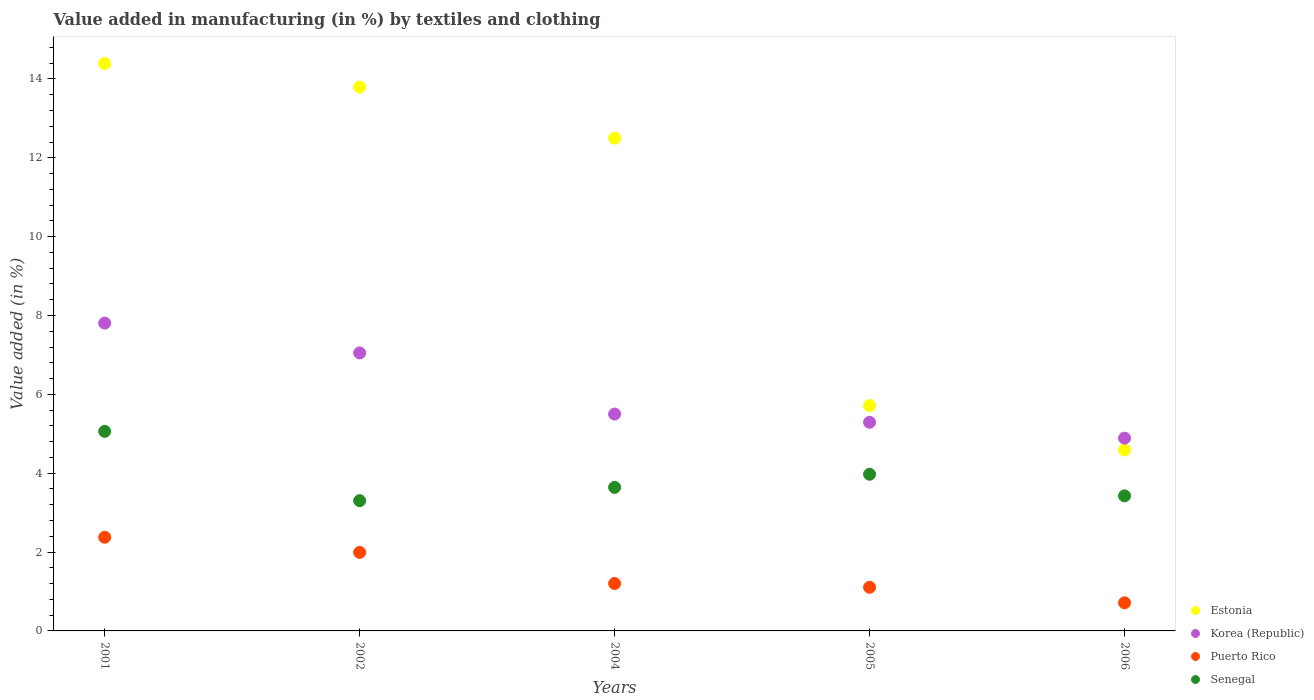How many different coloured dotlines are there?
Your answer should be very brief. 4. What is the percentage of value added in manufacturing by textiles and clothing in Senegal in 2005?
Offer a terse response. 3.97. Across all years, what is the maximum percentage of value added in manufacturing by textiles and clothing in Estonia?
Provide a short and direct response. 14.39. Across all years, what is the minimum percentage of value added in manufacturing by textiles and clothing in Korea (Republic)?
Offer a terse response. 4.89. In which year was the percentage of value added in manufacturing by textiles and clothing in Senegal minimum?
Provide a succinct answer. 2002. What is the total percentage of value added in manufacturing by textiles and clothing in Senegal in the graph?
Your response must be concise. 19.41. What is the difference between the percentage of value added in manufacturing by textiles and clothing in Puerto Rico in 2002 and that in 2005?
Make the answer very short. 0.88. What is the difference between the percentage of value added in manufacturing by textiles and clothing in Senegal in 2004 and the percentage of value added in manufacturing by textiles and clothing in Puerto Rico in 2005?
Offer a very short reply. 2.53. What is the average percentage of value added in manufacturing by textiles and clothing in Korea (Republic) per year?
Make the answer very short. 6.11. In the year 2004, what is the difference between the percentage of value added in manufacturing by textiles and clothing in Korea (Republic) and percentage of value added in manufacturing by textiles and clothing in Estonia?
Provide a succinct answer. -7. What is the ratio of the percentage of value added in manufacturing by textiles and clothing in Korea (Republic) in 2002 to that in 2006?
Offer a terse response. 1.44. Is the difference between the percentage of value added in manufacturing by textiles and clothing in Korea (Republic) in 2001 and 2005 greater than the difference between the percentage of value added in manufacturing by textiles and clothing in Estonia in 2001 and 2005?
Keep it short and to the point. No. What is the difference between the highest and the second highest percentage of value added in manufacturing by textiles and clothing in Senegal?
Offer a very short reply. 1.09. What is the difference between the highest and the lowest percentage of value added in manufacturing by textiles and clothing in Puerto Rico?
Make the answer very short. 1.66. Is the sum of the percentage of value added in manufacturing by textiles and clothing in Korea (Republic) in 2001 and 2006 greater than the maximum percentage of value added in manufacturing by textiles and clothing in Puerto Rico across all years?
Offer a terse response. Yes. Is it the case that in every year, the sum of the percentage of value added in manufacturing by textiles and clothing in Senegal and percentage of value added in manufacturing by textiles and clothing in Puerto Rico  is greater than the sum of percentage of value added in manufacturing by textiles and clothing in Estonia and percentage of value added in manufacturing by textiles and clothing in Korea (Republic)?
Provide a succinct answer. No. Does the percentage of value added in manufacturing by textiles and clothing in Puerto Rico monotonically increase over the years?
Provide a succinct answer. No. How many dotlines are there?
Keep it short and to the point. 4. How many years are there in the graph?
Offer a very short reply. 5. Are the values on the major ticks of Y-axis written in scientific E-notation?
Your answer should be very brief. No. How are the legend labels stacked?
Your response must be concise. Vertical. What is the title of the graph?
Keep it short and to the point. Value added in manufacturing (in %) by textiles and clothing. Does "Other small states" appear as one of the legend labels in the graph?
Offer a very short reply. No. What is the label or title of the X-axis?
Keep it short and to the point. Years. What is the label or title of the Y-axis?
Keep it short and to the point. Value added (in %). What is the Value added (in %) of Estonia in 2001?
Offer a very short reply. 14.39. What is the Value added (in %) of Korea (Republic) in 2001?
Your response must be concise. 7.81. What is the Value added (in %) of Puerto Rico in 2001?
Ensure brevity in your answer.  2.38. What is the Value added (in %) of Senegal in 2001?
Keep it short and to the point. 5.06. What is the Value added (in %) in Estonia in 2002?
Ensure brevity in your answer.  13.79. What is the Value added (in %) in Korea (Republic) in 2002?
Make the answer very short. 7.05. What is the Value added (in %) of Puerto Rico in 2002?
Offer a very short reply. 1.99. What is the Value added (in %) of Senegal in 2002?
Offer a very short reply. 3.3. What is the Value added (in %) of Estonia in 2004?
Provide a short and direct response. 12.5. What is the Value added (in %) of Korea (Republic) in 2004?
Give a very brief answer. 5.5. What is the Value added (in %) in Puerto Rico in 2004?
Give a very brief answer. 1.2. What is the Value added (in %) of Senegal in 2004?
Give a very brief answer. 3.64. What is the Value added (in %) of Estonia in 2005?
Your answer should be compact. 5.72. What is the Value added (in %) in Korea (Republic) in 2005?
Keep it short and to the point. 5.29. What is the Value added (in %) of Puerto Rico in 2005?
Provide a short and direct response. 1.11. What is the Value added (in %) in Senegal in 2005?
Your answer should be very brief. 3.97. What is the Value added (in %) in Estonia in 2006?
Offer a very short reply. 4.59. What is the Value added (in %) in Korea (Republic) in 2006?
Offer a very short reply. 4.89. What is the Value added (in %) in Puerto Rico in 2006?
Provide a short and direct response. 0.71. What is the Value added (in %) in Senegal in 2006?
Your answer should be very brief. 3.43. Across all years, what is the maximum Value added (in %) of Estonia?
Your answer should be very brief. 14.39. Across all years, what is the maximum Value added (in %) of Korea (Republic)?
Offer a very short reply. 7.81. Across all years, what is the maximum Value added (in %) of Puerto Rico?
Provide a short and direct response. 2.38. Across all years, what is the maximum Value added (in %) in Senegal?
Your response must be concise. 5.06. Across all years, what is the minimum Value added (in %) of Estonia?
Provide a short and direct response. 4.59. Across all years, what is the minimum Value added (in %) in Korea (Republic)?
Ensure brevity in your answer.  4.89. Across all years, what is the minimum Value added (in %) of Puerto Rico?
Your response must be concise. 0.71. Across all years, what is the minimum Value added (in %) in Senegal?
Your response must be concise. 3.3. What is the total Value added (in %) of Estonia in the graph?
Your response must be concise. 50.99. What is the total Value added (in %) in Korea (Republic) in the graph?
Offer a very short reply. 30.54. What is the total Value added (in %) in Puerto Rico in the graph?
Your answer should be very brief. 7.39. What is the total Value added (in %) in Senegal in the graph?
Ensure brevity in your answer.  19.41. What is the difference between the Value added (in %) of Estonia in 2001 and that in 2002?
Give a very brief answer. 0.6. What is the difference between the Value added (in %) in Korea (Republic) in 2001 and that in 2002?
Offer a terse response. 0.76. What is the difference between the Value added (in %) of Puerto Rico in 2001 and that in 2002?
Provide a succinct answer. 0.38. What is the difference between the Value added (in %) in Senegal in 2001 and that in 2002?
Keep it short and to the point. 1.76. What is the difference between the Value added (in %) of Estonia in 2001 and that in 2004?
Provide a succinct answer. 1.89. What is the difference between the Value added (in %) of Korea (Republic) in 2001 and that in 2004?
Ensure brevity in your answer.  2.31. What is the difference between the Value added (in %) in Puerto Rico in 2001 and that in 2004?
Your answer should be very brief. 1.17. What is the difference between the Value added (in %) in Senegal in 2001 and that in 2004?
Provide a succinct answer. 1.42. What is the difference between the Value added (in %) of Estonia in 2001 and that in 2005?
Your answer should be very brief. 8.67. What is the difference between the Value added (in %) of Korea (Republic) in 2001 and that in 2005?
Keep it short and to the point. 2.52. What is the difference between the Value added (in %) of Puerto Rico in 2001 and that in 2005?
Give a very brief answer. 1.27. What is the difference between the Value added (in %) of Senegal in 2001 and that in 2005?
Provide a succinct answer. 1.09. What is the difference between the Value added (in %) of Estonia in 2001 and that in 2006?
Provide a succinct answer. 9.8. What is the difference between the Value added (in %) of Korea (Republic) in 2001 and that in 2006?
Give a very brief answer. 2.92. What is the difference between the Value added (in %) of Puerto Rico in 2001 and that in 2006?
Keep it short and to the point. 1.66. What is the difference between the Value added (in %) in Senegal in 2001 and that in 2006?
Make the answer very short. 1.64. What is the difference between the Value added (in %) of Estonia in 2002 and that in 2004?
Keep it short and to the point. 1.3. What is the difference between the Value added (in %) in Korea (Republic) in 2002 and that in 2004?
Provide a succinct answer. 1.55. What is the difference between the Value added (in %) of Puerto Rico in 2002 and that in 2004?
Offer a very short reply. 0.79. What is the difference between the Value added (in %) in Senegal in 2002 and that in 2004?
Keep it short and to the point. -0.34. What is the difference between the Value added (in %) in Estonia in 2002 and that in 2005?
Offer a very short reply. 8.08. What is the difference between the Value added (in %) of Korea (Republic) in 2002 and that in 2005?
Offer a terse response. 1.76. What is the difference between the Value added (in %) in Puerto Rico in 2002 and that in 2005?
Your answer should be very brief. 0.88. What is the difference between the Value added (in %) of Senegal in 2002 and that in 2005?
Your answer should be compact. -0.67. What is the difference between the Value added (in %) in Estonia in 2002 and that in 2006?
Your answer should be compact. 9.2. What is the difference between the Value added (in %) in Korea (Republic) in 2002 and that in 2006?
Ensure brevity in your answer.  2.16. What is the difference between the Value added (in %) of Puerto Rico in 2002 and that in 2006?
Your answer should be very brief. 1.28. What is the difference between the Value added (in %) of Senegal in 2002 and that in 2006?
Offer a terse response. -0.12. What is the difference between the Value added (in %) in Estonia in 2004 and that in 2005?
Make the answer very short. 6.78. What is the difference between the Value added (in %) in Korea (Republic) in 2004 and that in 2005?
Offer a very short reply. 0.21. What is the difference between the Value added (in %) in Puerto Rico in 2004 and that in 2005?
Keep it short and to the point. 0.1. What is the difference between the Value added (in %) in Senegal in 2004 and that in 2005?
Make the answer very short. -0.33. What is the difference between the Value added (in %) in Estonia in 2004 and that in 2006?
Provide a short and direct response. 7.91. What is the difference between the Value added (in %) of Korea (Republic) in 2004 and that in 2006?
Make the answer very short. 0.61. What is the difference between the Value added (in %) of Puerto Rico in 2004 and that in 2006?
Your answer should be very brief. 0.49. What is the difference between the Value added (in %) of Senegal in 2004 and that in 2006?
Offer a terse response. 0.22. What is the difference between the Value added (in %) in Estonia in 2005 and that in 2006?
Offer a very short reply. 1.13. What is the difference between the Value added (in %) of Korea (Republic) in 2005 and that in 2006?
Offer a terse response. 0.4. What is the difference between the Value added (in %) in Puerto Rico in 2005 and that in 2006?
Keep it short and to the point. 0.39. What is the difference between the Value added (in %) of Senegal in 2005 and that in 2006?
Ensure brevity in your answer.  0.55. What is the difference between the Value added (in %) in Estonia in 2001 and the Value added (in %) in Korea (Republic) in 2002?
Offer a very short reply. 7.34. What is the difference between the Value added (in %) of Estonia in 2001 and the Value added (in %) of Puerto Rico in 2002?
Your response must be concise. 12.4. What is the difference between the Value added (in %) in Estonia in 2001 and the Value added (in %) in Senegal in 2002?
Provide a succinct answer. 11.09. What is the difference between the Value added (in %) of Korea (Republic) in 2001 and the Value added (in %) of Puerto Rico in 2002?
Give a very brief answer. 5.82. What is the difference between the Value added (in %) of Korea (Republic) in 2001 and the Value added (in %) of Senegal in 2002?
Make the answer very short. 4.5. What is the difference between the Value added (in %) of Puerto Rico in 2001 and the Value added (in %) of Senegal in 2002?
Your answer should be very brief. -0.93. What is the difference between the Value added (in %) of Estonia in 2001 and the Value added (in %) of Korea (Republic) in 2004?
Your answer should be compact. 8.89. What is the difference between the Value added (in %) of Estonia in 2001 and the Value added (in %) of Puerto Rico in 2004?
Your answer should be very brief. 13.19. What is the difference between the Value added (in %) in Estonia in 2001 and the Value added (in %) in Senegal in 2004?
Keep it short and to the point. 10.75. What is the difference between the Value added (in %) in Korea (Republic) in 2001 and the Value added (in %) in Puerto Rico in 2004?
Provide a succinct answer. 6.6. What is the difference between the Value added (in %) in Korea (Republic) in 2001 and the Value added (in %) in Senegal in 2004?
Provide a short and direct response. 4.17. What is the difference between the Value added (in %) of Puerto Rico in 2001 and the Value added (in %) of Senegal in 2004?
Your answer should be compact. -1.27. What is the difference between the Value added (in %) of Estonia in 2001 and the Value added (in %) of Korea (Republic) in 2005?
Provide a short and direct response. 9.1. What is the difference between the Value added (in %) of Estonia in 2001 and the Value added (in %) of Puerto Rico in 2005?
Offer a terse response. 13.28. What is the difference between the Value added (in %) of Estonia in 2001 and the Value added (in %) of Senegal in 2005?
Make the answer very short. 10.42. What is the difference between the Value added (in %) in Korea (Republic) in 2001 and the Value added (in %) in Puerto Rico in 2005?
Offer a very short reply. 6.7. What is the difference between the Value added (in %) of Korea (Republic) in 2001 and the Value added (in %) of Senegal in 2005?
Give a very brief answer. 3.83. What is the difference between the Value added (in %) in Puerto Rico in 2001 and the Value added (in %) in Senegal in 2005?
Your response must be concise. -1.6. What is the difference between the Value added (in %) in Estonia in 2001 and the Value added (in %) in Korea (Republic) in 2006?
Your answer should be very brief. 9.5. What is the difference between the Value added (in %) in Estonia in 2001 and the Value added (in %) in Puerto Rico in 2006?
Offer a very short reply. 13.68. What is the difference between the Value added (in %) in Estonia in 2001 and the Value added (in %) in Senegal in 2006?
Provide a short and direct response. 10.97. What is the difference between the Value added (in %) of Korea (Republic) in 2001 and the Value added (in %) of Puerto Rico in 2006?
Provide a succinct answer. 7.09. What is the difference between the Value added (in %) of Korea (Republic) in 2001 and the Value added (in %) of Senegal in 2006?
Provide a short and direct response. 4.38. What is the difference between the Value added (in %) in Puerto Rico in 2001 and the Value added (in %) in Senegal in 2006?
Keep it short and to the point. -1.05. What is the difference between the Value added (in %) in Estonia in 2002 and the Value added (in %) in Korea (Republic) in 2004?
Keep it short and to the point. 8.29. What is the difference between the Value added (in %) of Estonia in 2002 and the Value added (in %) of Puerto Rico in 2004?
Keep it short and to the point. 12.59. What is the difference between the Value added (in %) of Estonia in 2002 and the Value added (in %) of Senegal in 2004?
Provide a succinct answer. 10.15. What is the difference between the Value added (in %) in Korea (Republic) in 2002 and the Value added (in %) in Puerto Rico in 2004?
Give a very brief answer. 5.85. What is the difference between the Value added (in %) in Korea (Republic) in 2002 and the Value added (in %) in Senegal in 2004?
Offer a terse response. 3.41. What is the difference between the Value added (in %) of Puerto Rico in 2002 and the Value added (in %) of Senegal in 2004?
Offer a very short reply. -1.65. What is the difference between the Value added (in %) of Estonia in 2002 and the Value added (in %) of Korea (Republic) in 2005?
Offer a terse response. 8.5. What is the difference between the Value added (in %) in Estonia in 2002 and the Value added (in %) in Puerto Rico in 2005?
Your answer should be very brief. 12.69. What is the difference between the Value added (in %) of Estonia in 2002 and the Value added (in %) of Senegal in 2005?
Your answer should be very brief. 9.82. What is the difference between the Value added (in %) in Korea (Republic) in 2002 and the Value added (in %) in Puerto Rico in 2005?
Ensure brevity in your answer.  5.94. What is the difference between the Value added (in %) of Korea (Republic) in 2002 and the Value added (in %) of Senegal in 2005?
Give a very brief answer. 3.08. What is the difference between the Value added (in %) in Puerto Rico in 2002 and the Value added (in %) in Senegal in 2005?
Keep it short and to the point. -1.98. What is the difference between the Value added (in %) in Estonia in 2002 and the Value added (in %) in Korea (Republic) in 2006?
Provide a short and direct response. 8.9. What is the difference between the Value added (in %) of Estonia in 2002 and the Value added (in %) of Puerto Rico in 2006?
Make the answer very short. 13.08. What is the difference between the Value added (in %) of Estonia in 2002 and the Value added (in %) of Senegal in 2006?
Provide a short and direct response. 10.37. What is the difference between the Value added (in %) of Korea (Republic) in 2002 and the Value added (in %) of Puerto Rico in 2006?
Provide a short and direct response. 6.34. What is the difference between the Value added (in %) in Korea (Republic) in 2002 and the Value added (in %) in Senegal in 2006?
Keep it short and to the point. 3.63. What is the difference between the Value added (in %) in Puerto Rico in 2002 and the Value added (in %) in Senegal in 2006?
Your response must be concise. -1.43. What is the difference between the Value added (in %) in Estonia in 2004 and the Value added (in %) in Korea (Republic) in 2005?
Offer a very short reply. 7.21. What is the difference between the Value added (in %) in Estonia in 2004 and the Value added (in %) in Puerto Rico in 2005?
Offer a terse response. 11.39. What is the difference between the Value added (in %) of Estonia in 2004 and the Value added (in %) of Senegal in 2005?
Provide a short and direct response. 8.53. What is the difference between the Value added (in %) in Korea (Republic) in 2004 and the Value added (in %) in Puerto Rico in 2005?
Ensure brevity in your answer.  4.39. What is the difference between the Value added (in %) in Korea (Republic) in 2004 and the Value added (in %) in Senegal in 2005?
Ensure brevity in your answer.  1.53. What is the difference between the Value added (in %) of Puerto Rico in 2004 and the Value added (in %) of Senegal in 2005?
Give a very brief answer. -2.77. What is the difference between the Value added (in %) of Estonia in 2004 and the Value added (in %) of Korea (Republic) in 2006?
Provide a short and direct response. 7.61. What is the difference between the Value added (in %) in Estonia in 2004 and the Value added (in %) in Puerto Rico in 2006?
Offer a terse response. 11.79. What is the difference between the Value added (in %) of Estonia in 2004 and the Value added (in %) of Senegal in 2006?
Your response must be concise. 9.07. What is the difference between the Value added (in %) in Korea (Republic) in 2004 and the Value added (in %) in Puerto Rico in 2006?
Keep it short and to the point. 4.79. What is the difference between the Value added (in %) of Korea (Republic) in 2004 and the Value added (in %) of Senegal in 2006?
Your answer should be very brief. 2.07. What is the difference between the Value added (in %) of Puerto Rico in 2004 and the Value added (in %) of Senegal in 2006?
Offer a very short reply. -2.22. What is the difference between the Value added (in %) of Estonia in 2005 and the Value added (in %) of Korea (Republic) in 2006?
Your answer should be compact. 0.83. What is the difference between the Value added (in %) of Estonia in 2005 and the Value added (in %) of Puerto Rico in 2006?
Make the answer very short. 5. What is the difference between the Value added (in %) in Estonia in 2005 and the Value added (in %) in Senegal in 2006?
Give a very brief answer. 2.29. What is the difference between the Value added (in %) in Korea (Republic) in 2005 and the Value added (in %) in Puerto Rico in 2006?
Ensure brevity in your answer.  4.58. What is the difference between the Value added (in %) in Korea (Republic) in 2005 and the Value added (in %) in Senegal in 2006?
Your answer should be very brief. 1.87. What is the difference between the Value added (in %) of Puerto Rico in 2005 and the Value added (in %) of Senegal in 2006?
Your answer should be compact. -2.32. What is the average Value added (in %) of Estonia per year?
Your answer should be compact. 10.2. What is the average Value added (in %) in Korea (Republic) per year?
Ensure brevity in your answer.  6.11. What is the average Value added (in %) in Puerto Rico per year?
Keep it short and to the point. 1.48. What is the average Value added (in %) in Senegal per year?
Your response must be concise. 3.88. In the year 2001, what is the difference between the Value added (in %) of Estonia and Value added (in %) of Korea (Republic)?
Provide a short and direct response. 6.58. In the year 2001, what is the difference between the Value added (in %) in Estonia and Value added (in %) in Puerto Rico?
Give a very brief answer. 12.02. In the year 2001, what is the difference between the Value added (in %) in Estonia and Value added (in %) in Senegal?
Keep it short and to the point. 9.33. In the year 2001, what is the difference between the Value added (in %) in Korea (Republic) and Value added (in %) in Puerto Rico?
Ensure brevity in your answer.  5.43. In the year 2001, what is the difference between the Value added (in %) of Korea (Republic) and Value added (in %) of Senegal?
Offer a terse response. 2.75. In the year 2001, what is the difference between the Value added (in %) of Puerto Rico and Value added (in %) of Senegal?
Make the answer very short. -2.69. In the year 2002, what is the difference between the Value added (in %) of Estonia and Value added (in %) of Korea (Republic)?
Offer a very short reply. 6.74. In the year 2002, what is the difference between the Value added (in %) in Estonia and Value added (in %) in Puerto Rico?
Offer a terse response. 11.8. In the year 2002, what is the difference between the Value added (in %) in Estonia and Value added (in %) in Senegal?
Provide a succinct answer. 10.49. In the year 2002, what is the difference between the Value added (in %) in Korea (Republic) and Value added (in %) in Puerto Rico?
Provide a short and direct response. 5.06. In the year 2002, what is the difference between the Value added (in %) of Korea (Republic) and Value added (in %) of Senegal?
Give a very brief answer. 3.75. In the year 2002, what is the difference between the Value added (in %) of Puerto Rico and Value added (in %) of Senegal?
Offer a terse response. -1.31. In the year 2004, what is the difference between the Value added (in %) of Estonia and Value added (in %) of Korea (Republic)?
Your response must be concise. 7. In the year 2004, what is the difference between the Value added (in %) in Estonia and Value added (in %) in Puerto Rico?
Ensure brevity in your answer.  11.3. In the year 2004, what is the difference between the Value added (in %) in Estonia and Value added (in %) in Senegal?
Offer a very short reply. 8.86. In the year 2004, what is the difference between the Value added (in %) in Korea (Republic) and Value added (in %) in Puerto Rico?
Make the answer very short. 4.3. In the year 2004, what is the difference between the Value added (in %) in Korea (Republic) and Value added (in %) in Senegal?
Provide a short and direct response. 1.86. In the year 2004, what is the difference between the Value added (in %) in Puerto Rico and Value added (in %) in Senegal?
Ensure brevity in your answer.  -2.44. In the year 2005, what is the difference between the Value added (in %) of Estonia and Value added (in %) of Korea (Republic)?
Provide a short and direct response. 0.43. In the year 2005, what is the difference between the Value added (in %) of Estonia and Value added (in %) of Puerto Rico?
Offer a terse response. 4.61. In the year 2005, what is the difference between the Value added (in %) in Estonia and Value added (in %) in Senegal?
Keep it short and to the point. 1.74. In the year 2005, what is the difference between the Value added (in %) of Korea (Republic) and Value added (in %) of Puerto Rico?
Your answer should be compact. 4.18. In the year 2005, what is the difference between the Value added (in %) in Korea (Republic) and Value added (in %) in Senegal?
Offer a terse response. 1.32. In the year 2005, what is the difference between the Value added (in %) in Puerto Rico and Value added (in %) in Senegal?
Give a very brief answer. -2.87. In the year 2006, what is the difference between the Value added (in %) in Estonia and Value added (in %) in Korea (Republic)?
Your answer should be compact. -0.3. In the year 2006, what is the difference between the Value added (in %) of Estonia and Value added (in %) of Puerto Rico?
Offer a very short reply. 3.88. In the year 2006, what is the difference between the Value added (in %) in Estonia and Value added (in %) in Senegal?
Provide a short and direct response. 1.16. In the year 2006, what is the difference between the Value added (in %) in Korea (Republic) and Value added (in %) in Puerto Rico?
Ensure brevity in your answer.  4.18. In the year 2006, what is the difference between the Value added (in %) of Korea (Republic) and Value added (in %) of Senegal?
Ensure brevity in your answer.  1.46. In the year 2006, what is the difference between the Value added (in %) of Puerto Rico and Value added (in %) of Senegal?
Ensure brevity in your answer.  -2.71. What is the ratio of the Value added (in %) in Estonia in 2001 to that in 2002?
Your answer should be very brief. 1.04. What is the ratio of the Value added (in %) of Korea (Republic) in 2001 to that in 2002?
Keep it short and to the point. 1.11. What is the ratio of the Value added (in %) in Puerto Rico in 2001 to that in 2002?
Offer a very short reply. 1.19. What is the ratio of the Value added (in %) in Senegal in 2001 to that in 2002?
Keep it short and to the point. 1.53. What is the ratio of the Value added (in %) of Estonia in 2001 to that in 2004?
Make the answer very short. 1.15. What is the ratio of the Value added (in %) of Korea (Republic) in 2001 to that in 2004?
Provide a short and direct response. 1.42. What is the ratio of the Value added (in %) in Puerto Rico in 2001 to that in 2004?
Keep it short and to the point. 1.98. What is the ratio of the Value added (in %) of Senegal in 2001 to that in 2004?
Provide a short and direct response. 1.39. What is the ratio of the Value added (in %) of Estonia in 2001 to that in 2005?
Provide a succinct answer. 2.52. What is the ratio of the Value added (in %) of Korea (Republic) in 2001 to that in 2005?
Your response must be concise. 1.48. What is the ratio of the Value added (in %) in Puerto Rico in 2001 to that in 2005?
Offer a very short reply. 2.15. What is the ratio of the Value added (in %) in Senegal in 2001 to that in 2005?
Make the answer very short. 1.27. What is the ratio of the Value added (in %) in Estonia in 2001 to that in 2006?
Offer a very short reply. 3.14. What is the ratio of the Value added (in %) of Korea (Republic) in 2001 to that in 2006?
Provide a short and direct response. 1.6. What is the ratio of the Value added (in %) in Puerto Rico in 2001 to that in 2006?
Provide a succinct answer. 3.33. What is the ratio of the Value added (in %) of Senegal in 2001 to that in 2006?
Ensure brevity in your answer.  1.48. What is the ratio of the Value added (in %) of Estonia in 2002 to that in 2004?
Make the answer very short. 1.1. What is the ratio of the Value added (in %) in Korea (Republic) in 2002 to that in 2004?
Provide a succinct answer. 1.28. What is the ratio of the Value added (in %) in Puerto Rico in 2002 to that in 2004?
Your response must be concise. 1.66. What is the ratio of the Value added (in %) in Senegal in 2002 to that in 2004?
Your answer should be very brief. 0.91. What is the ratio of the Value added (in %) in Estonia in 2002 to that in 2005?
Your answer should be compact. 2.41. What is the ratio of the Value added (in %) in Korea (Republic) in 2002 to that in 2005?
Provide a short and direct response. 1.33. What is the ratio of the Value added (in %) in Puerto Rico in 2002 to that in 2005?
Provide a succinct answer. 1.8. What is the ratio of the Value added (in %) of Senegal in 2002 to that in 2005?
Your response must be concise. 0.83. What is the ratio of the Value added (in %) of Estonia in 2002 to that in 2006?
Provide a short and direct response. 3.01. What is the ratio of the Value added (in %) in Korea (Republic) in 2002 to that in 2006?
Ensure brevity in your answer.  1.44. What is the ratio of the Value added (in %) in Puerto Rico in 2002 to that in 2006?
Your answer should be very brief. 2.79. What is the ratio of the Value added (in %) of Senegal in 2002 to that in 2006?
Your response must be concise. 0.96. What is the ratio of the Value added (in %) of Estonia in 2004 to that in 2005?
Keep it short and to the point. 2.19. What is the ratio of the Value added (in %) in Korea (Republic) in 2004 to that in 2005?
Your answer should be very brief. 1.04. What is the ratio of the Value added (in %) of Puerto Rico in 2004 to that in 2005?
Your response must be concise. 1.09. What is the ratio of the Value added (in %) in Senegal in 2004 to that in 2005?
Offer a terse response. 0.92. What is the ratio of the Value added (in %) in Estonia in 2004 to that in 2006?
Your answer should be compact. 2.72. What is the ratio of the Value added (in %) of Korea (Republic) in 2004 to that in 2006?
Provide a short and direct response. 1.12. What is the ratio of the Value added (in %) of Puerto Rico in 2004 to that in 2006?
Offer a very short reply. 1.69. What is the ratio of the Value added (in %) of Senegal in 2004 to that in 2006?
Your answer should be compact. 1.06. What is the ratio of the Value added (in %) of Estonia in 2005 to that in 2006?
Your response must be concise. 1.25. What is the ratio of the Value added (in %) of Korea (Republic) in 2005 to that in 2006?
Provide a succinct answer. 1.08. What is the ratio of the Value added (in %) in Puerto Rico in 2005 to that in 2006?
Make the answer very short. 1.55. What is the ratio of the Value added (in %) in Senegal in 2005 to that in 2006?
Your answer should be compact. 1.16. What is the difference between the highest and the second highest Value added (in %) of Estonia?
Offer a very short reply. 0.6. What is the difference between the highest and the second highest Value added (in %) of Korea (Republic)?
Keep it short and to the point. 0.76. What is the difference between the highest and the second highest Value added (in %) in Puerto Rico?
Make the answer very short. 0.38. What is the difference between the highest and the second highest Value added (in %) of Senegal?
Your answer should be very brief. 1.09. What is the difference between the highest and the lowest Value added (in %) of Estonia?
Give a very brief answer. 9.8. What is the difference between the highest and the lowest Value added (in %) of Korea (Republic)?
Offer a very short reply. 2.92. What is the difference between the highest and the lowest Value added (in %) in Puerto Rico?
Give a very brief answer. 1.66. What is the difference between the highest and the lowest Value added (in %) of Senegal?
Offer a very short reply. 1.76. 